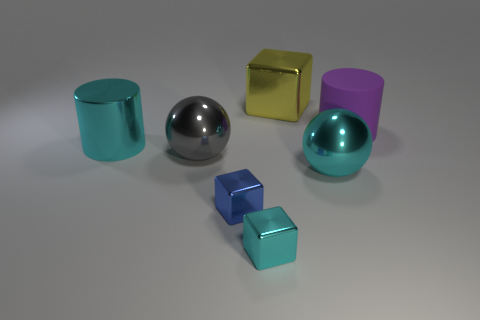Add 1 blue shiny blocks. How many objects exist? 8 Subtract all balls. How many objects are left? 5 Subtract all green matte cylinders. Subtract all gray things. How many objects are left? 6 Add 1 metal cylinders. How many metal cylinders are left? 2 Add 4 tiny yellow things. How many tiny yellow things exist? 4 Subtract 0 gray blocks. How many objects are left? 7 